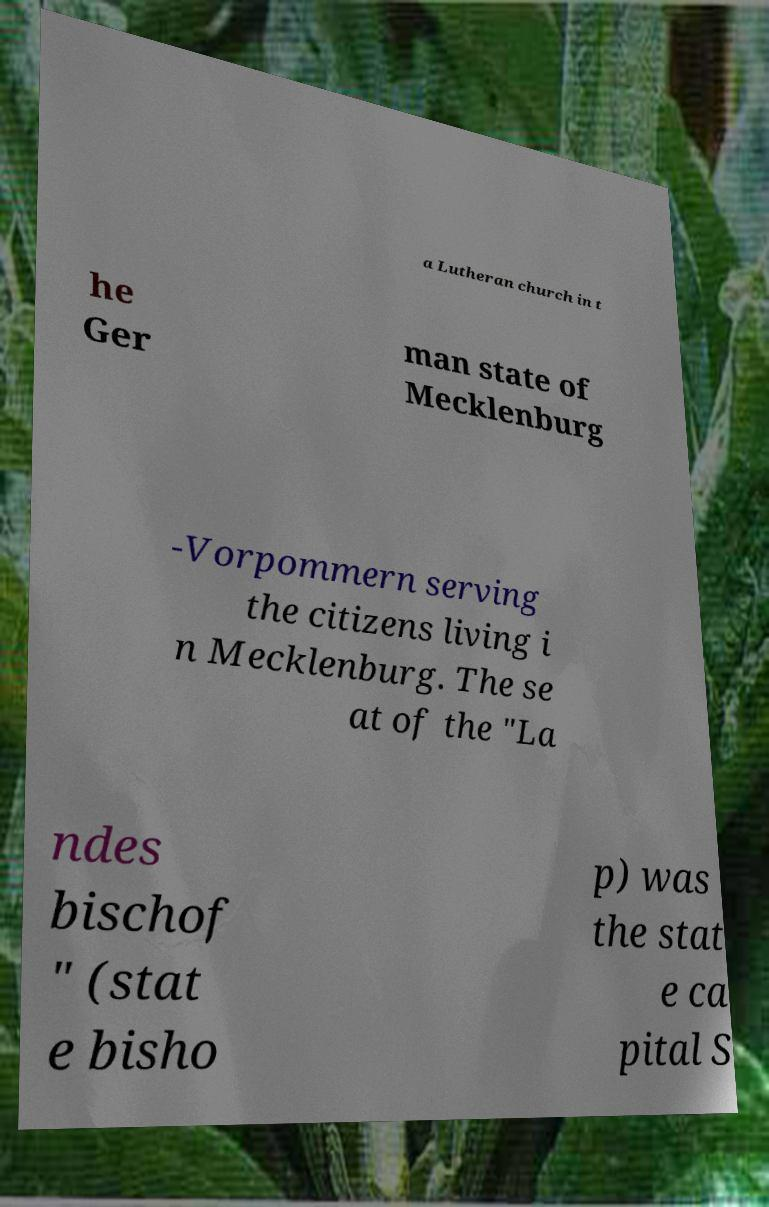For documentation purposes, I need the text within this image transcribed. Could you provide that? a Lutheran church in t he Ger man state of Mecklenburg -Vorpommern serving the citizens living i n Mecklenburg. The se at of the "La ndes bischof " (stat e bisho p) was the stat e ca pital S 